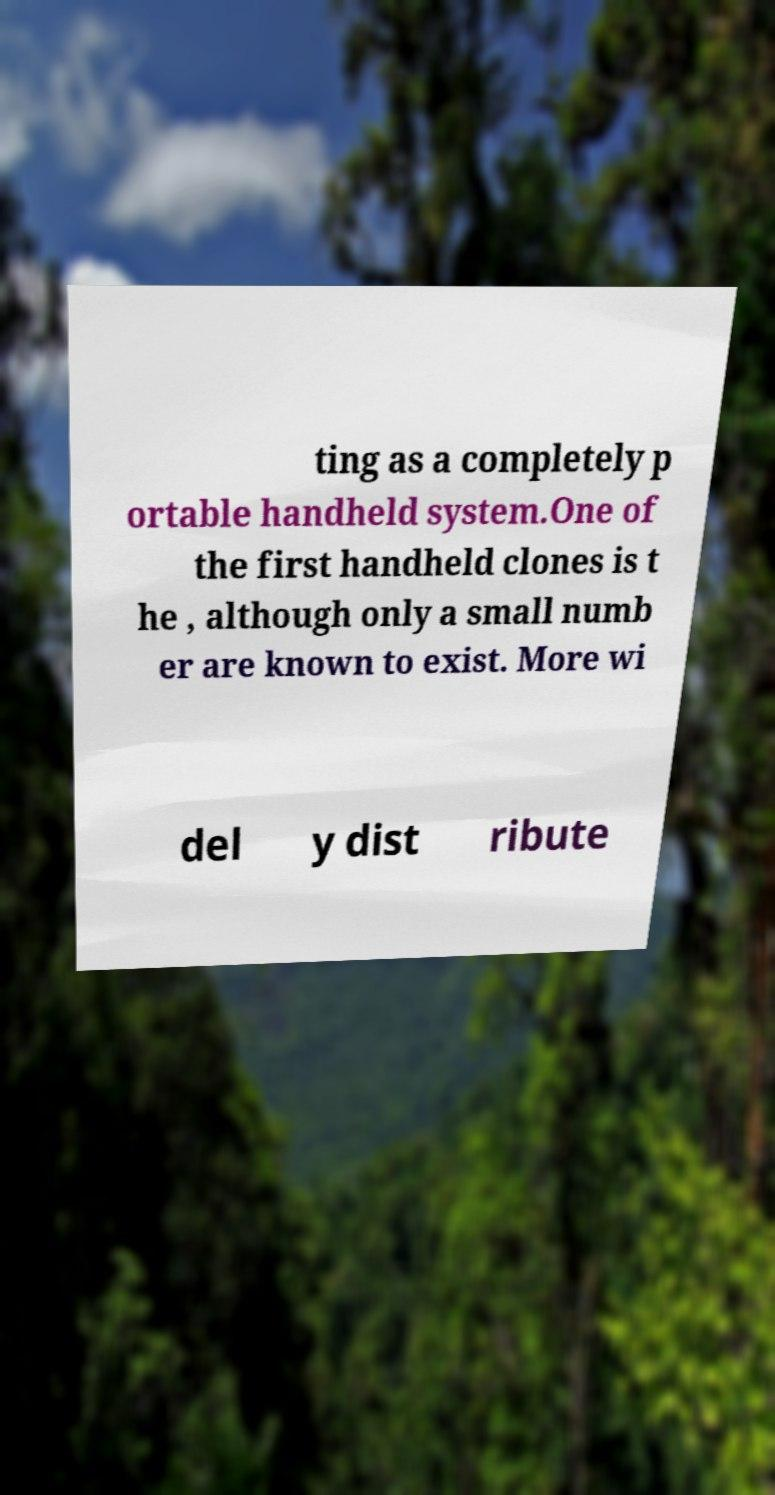For documentation purposes, I need the text within this image transcribed. Could you provide that? ting as a completely p ortable handheld system.One of the first handheld clones is t he , although only a small numb er are known to exist. More wi del y dist ribute 